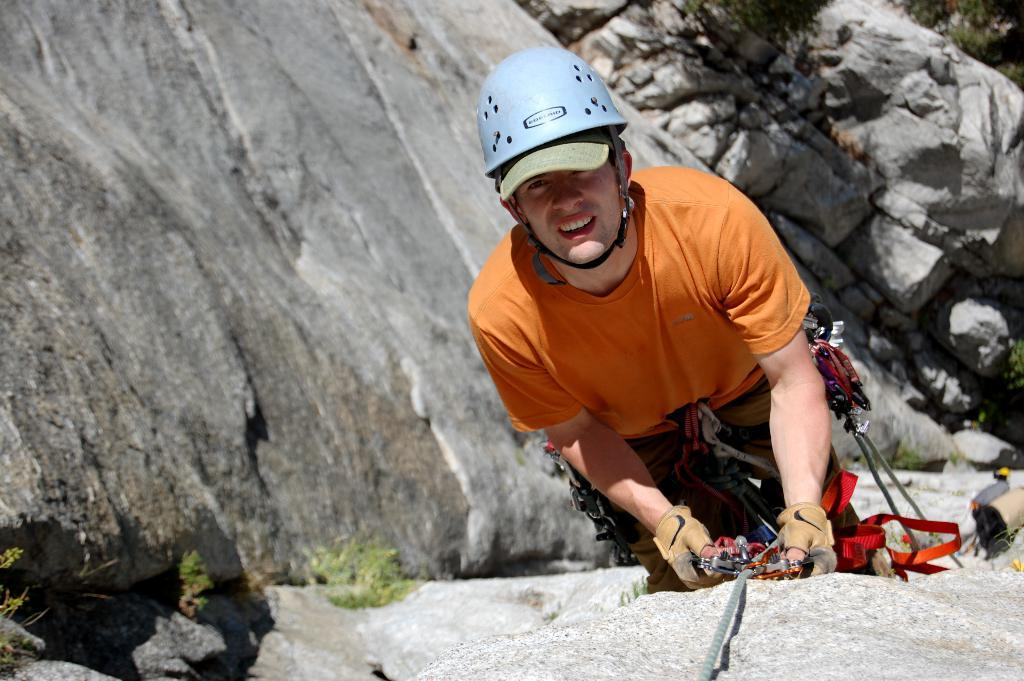What type of natural elements can be seen in the image? There are rocks in the image. What is the person wearing in the image? The person is wearing a helmet and gloves in the image. What is the person holding in the image? The person is holding an object with a rope in the image. What type of vegetation is present in the image? There are plants in the image. What type of creature is protesting in the image? There is no creature or protest present in the image. How is the lock being used in the image? There is no lock present in the image. 